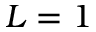Convert formula to latex. <formula><loc_0><loc_0><loc_500><loc_500>L = 1</formula> 